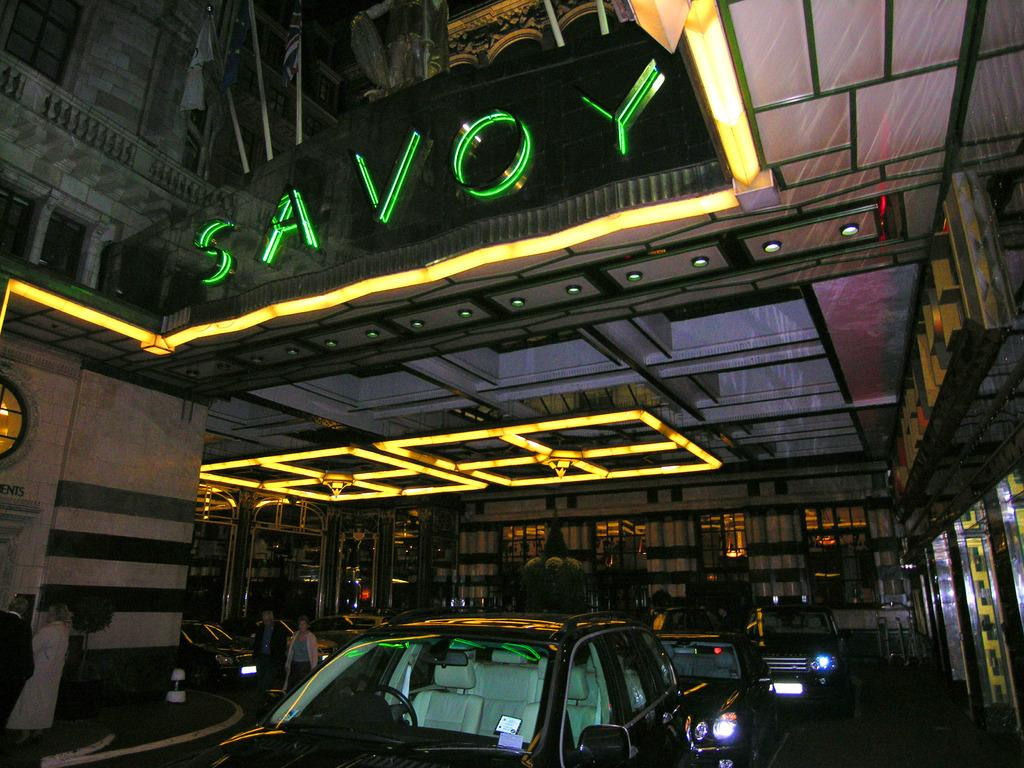<image>
Create a compact narrative representing the image presented. Some cars parked under a sign that says SAVOY on it. 